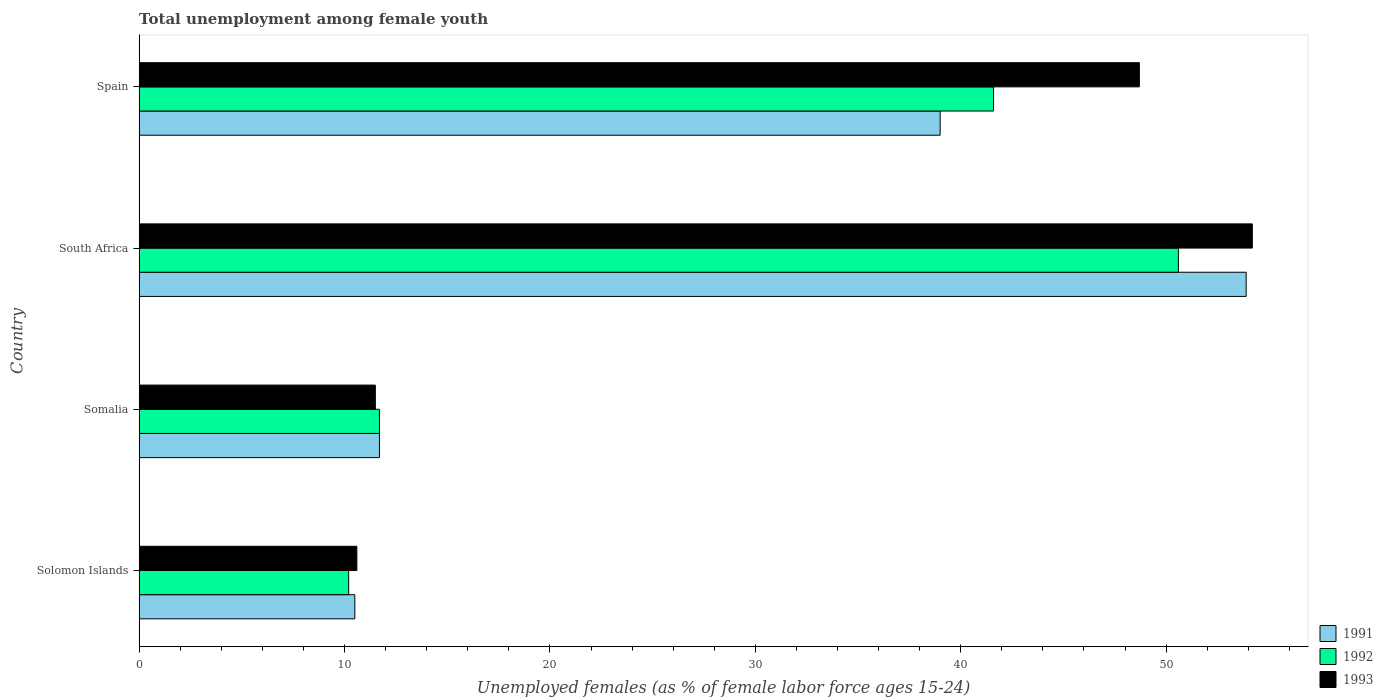How many different coloured bars are there?
Provide a succinct answer. 3. How many groups of bars are there?
Make the answer very short. 4. Are the number of bars per tick equal to the number of legend labels?
Ensure brevity in your answer.  Yes. How many bars are there on the 4th tick from the top?
Your answer should be compact. 3. What is the label of the 3rd group of bars from the top?
Provide a succinct answer. Somalia. Across all countries, what is the maximum percentage of unemployed females in in 1993?
Provide a short and direct response. 54.2. Across all countries, what is the minimum percentage of unemployed females in in 1992?
Provide a short and direct response. 10.2. In which country was the percentage of unemployed females in in 1991 maximum?
Ensure brevity in your answer.  South Africa. In which country was the percentage of unemployed females in in 1992 minimum?
Offer a terse response. Solomon Islands. What is the total percentage of unemployed females in in 1993 in the graph?
Provide a short and direct response. 125. What is the difference between the percentage of unemployed females in in 1993 in Solomon Islands and that in South Africa?
Ensure brevity in your answer.  -43.6. What is the difference between the percentage of unemployed females in in 1992 in Spain and the percentage of unemployed females in in 1993 in Solomon Islands?
Provide a succinct answer. 31. What is the average percentage of unemployed females in in 1993 per country?
Your answer should be very brief. 31.25. What is the difference between the percentage of unemployed females in in 1991 and percentage of unemployed females in in 1993 in Spain?
Ensure brevity in your answer.  -9.7. In how many countries, is the percentage of unemployed females in in 1993 greater than 16 %?
Provide a succinct answer. 2. What is the ratio of the percentage of unemployed females in in 1993 in Somalia to that in South Africa?
Ensure brevity in your answer.  0.21. What is the difference between the highest and the second highest percentage of unemployed females in in 1991?
Give a very brief answer. 14.9. What is the difference between the highest and the lowest percentage of unemployed females in in 1993?
Ensure brevity in your answer.  43.6. Is the sum of the percentage of unemployed females in in 1991 in South Africa and Spain greater than the maximum percentage of unemployed females in in 1993 across all countries?
Provide a succinct answer. Yes. What does the 2nd bar from the top in Somalia represents?
Your response must be concise. 1992. How many bars are there?
Make the answer very short. 12. How many countries are there in the graph?
Your answer should be compact. 4. What is the difference between two consecutive major ticks on the X-axis?
Your response must be concise. 10. Are the values on the major ticks of X-axis written in scientific E-notation?
Offer a very short reply. No. Does the graph contain any zero values?
Keep it short and to the point. No. Where does the legend appear in the graph?
Provide a succinct answer. Bottom right. What is the title of the graph?
Your answer should be compact. Total unemployment among female youth. Does "1997" appear as one of the legend labels in the graph?
Make the answer very short. No. What is the label or title of the X-axis?
Keep it short and to the point. Unemployed females (as % of female labor force ages 15-24). What is the label or title of the Y-axis?
Make the answer very short. Country. What is the Unemployed females (as % of female labor force ages 15-24) of 1991 in Solomon Islands?
Provide a short and direct response. 10.5. What is the Unemployed females (as % of female labor force ages 15-24) in 1992 in Solomon Islands?
Your answer should be compact. 10.2. What is the Unemployed females (as % of female labor force ages 15-24) of 1993 in Solomon Islands?
Provide a short and direct response. 10.6. What is the Unemployed females (as % of female labor force ages 15-24) of 1991 in Somalia?
Your response must be concise. 11.7. What is the Unemployed females (as % of female labor force ages 15-24) of 1992 in Somalia?
Offer a terse response. 11.7. What is the Unemployed females (as % of female labor force ages 15-24) of 1993 in Somalia?
Your response must be concise. 11.5. What is the Unemployed females (as % of female labor force ages 15-24) of 1991 in South Africa?
Your answer should be very brief. 53.9. What is the Unemployed females (as % of female labor force ages 15-24) in 1992 in South Africa?
Make the answer very short. 50.6. What is the Unemployed females (as % of female labor force ages 15-24) in 1993 in South Africa?
Ensure brevity in your answer.  54.2. What is the Unemployed females (as % of female labor force ages 15-24) in 1991 in Spain?
Give a very brief answer. 39. What is the Unemployed females (as % of female labor force ages 15-24) of 1992 in Spain?
Your answer should be very brief. 41.6. What is the Unemployed females (as % of female labor force ages 15-24) of 1993 in Spain?
Give a very brief answer. 48.7. Across all countries, what is the maximum Unemployed females (as % of female labor force ages 15-24) of 1991?
Offer a terse response. 53.9. Across all countries, what is the maximum Unemployed females (as % of female labor force ages 15-24) of 1992?
Provide a succinct answer. 50.6. Across all countries, what is the maximum Unemployed females (as % of female labor force ages 15-24) of 1993?
Keep it short and to the point. 54.2. Across all countries, what is the minimum Unemployed females (as % of female labor force ages 15-24) in 1991?
Make the answer very short. 10.5. Across all countries, what is the minimum Unemployed females (as % of female labor force ages 15-24) of 1992?
Ensure brevity in your answer.  10.2. Across all countries, what is the minimum Unemployed females (as % of female labor force ages 15-24) of 1993?
Give a very brief answer. 10.6. What is the total Unemployed females (as % of female labor force ages 15-24) in 1991 in the graph?
Your answer should be compact. 115.1. What is the total Unemployed females (as % of female labor force ages 15-24) of 1992 in the graph?
Keep it short and to the point. 114.1. What is the total Unemployed females (as % of female labor force ages 15-24) in 1993 in the graph?
Ensure brevity in your answer.  125. What is the difference between the Unemployed females (as % of female labor force ages 15-24) of 1991 in Solomon Islands and that in Somalia?
Your response must be concise. -1.2. What is the difference between the Unemployed females (as % of female labor force ages 15-24) of 1991 in Solomon Islands and that in South Africa?
Give a very brief answer. -43.4. What is the difference between the Unemployed females (as % of female labor force ages 15-24) of 1992 in Solomon Islands and that in South Africa?
Offer a very short reply. -40.4. What is the difference between the Unemployed females (as % of female labor force ages 15-24) in 1993 in Solomon Islands and that in South Africa?
Provide a short and direct response. -43.6. What is the difference between the Unemployed females (as % of female labor force ages 15-24) of 1991 in Solomon Islands and that in Spain?
Offer a terse response. -28.5. What is the difference between the Unemployed females (as % of female labor force ages 15-24) in 1992 in Solomon Islands and that in Spain?
Offer a terse response. -31.4. What is the difference between the Unemployed females (as % of female labor force ages 15-24) in 1993 in Solomon Islands and that in Spain?
Offer a very short reply. -38.1. What is the difference between the Unemployed females (as % of female labor force ages 15-24) of 1991 in Somalia and that in South Africa?
Make the answer very short. -42.2. What is the difference between the Unemployed females (as % of female labor force ages 15-24) in 1992 in Somalia and that in South Africa?
Your answer should be very brief. -38.9. What is the difference between the Unemployed females (as % of female labor force ages 15-24) of 1993 in Somalia and that in South Africa?
Your answer should be very brief. -42.7. What is the difference between the Unemployed females (as % of female labor force ages 15-24) in 1991 in Somalia and that in Spain?
Your answer should be very brief. -27.3. What is the difference between the Unemployed females (as % of female labor force ages 15-24) in 1992 in Somalia and that in Spain?
Your response must be concise. -29.9. What is the difference between the Unemployed females (as % of female labor force ages 15-24) in 1993 in Somalia and that in Spain?
Provide a short and direct response. -37.2. What is the difference between the Unemployed females (as % of female labor force ages 15-24) of 1992 in South Africa and that in Spain?
Your response must be concise. 9. What is the difference between the Unemployed females (as % of female labor force ages 15-24) of 1991 in Solomon Islands and the Unemployed females (as % of female labor force ages 15-24) of 1993 in Somalia?
Offer a terse response. -1. What is the difference between the Unemployed females (as % of female labor force ages 15-24) in 1992 in Solomon Islands and the Unemployed females (as % of female labor force ages 15-24) in 1993 in Somalia?
Your answer should be compact. -1.3. What is the difference between the Unemployed females (as % of female labor force ages 15-24) of 1991 in Solomon Islands and the Unemployed females (as % of female labor force ages 15-24) of 1992 in South Africa?
Ensure brevity in your answer.  -40.1. What is the difference between the Unemployed females (as % of female labor force ages 15-24) of 1991 in Solomon Islands and the Unemployed females (as % of female labor force ages 15-24) of 1993 in South Africa?
Provide a succinct answer. -43.7. What is the difference between the Unemployed females (as % of female labor force ages 15-24) of 1992 in Solomon Islands and the Unemployed females (as % of female labor force ages 15-24) of 1993 in South Africa?
Offer a terse response. -44. What is the difference between the Unemployed females (as % of female labor force ages 15-24) in 1991 in Solomon Islands and the Unemployed females (as % of female labor force ages 15-24) in 1992 in Spain?
Make the answer very short. -31.1. What is the difference between the Unemployed females (as % of female labor force ages 15-24) of 1991 in Solomon Islands and the Unemployed females (as % of female labor force ages 15-24) of 1993 in Spain?
Make the answer very short. -38.2. What is the difference between the Unemployed females (as % of female labor force ages 15-24) of 1992 in Solomon Islands and the Unemployed females (as % of female labor force ages 15-24) of 1993 in Spain?
Provide a succinct answer. -38.5. What is the difference between the Unemployed females (as % of female labor force ages 15-24) in 1991 in Somalia and the Unemployed females (as % of female labor force ages 15-24) in 1992 in South Africa?
Make the answer very short. -38.9. What is the difference between the Unemployed females (as % of female labor force ages 15-24) in 1991 in Somalia and the Unemployed females (as % of female labor force ages 15-24) in 1993 in South Africa?
Your answer should be compact. -42.5. What is the difference between the Unemployed females (as % of female labor force ages 15-24) of 1992 in Somalia and the Unemployed females (as % of female labor force ages 15-24) of 1993 in South Africa?
Give a very brief answer. -42.5. What is the difference between the Unemployed females (as % of female labor force ages 15-24) of 1991 in Somalia and the Unemployed females (as % of female labor force ages 15-24) of 1992 in Spain?
Keep it short and to the point. -29.9. What is the difference between the Unemployed females (as % of female labor force ages 15-24) in 1991 in Somalia and the Unemployed females (as % of female labor force ages 15-24) in 1993 in Spain?
Your answer should be very brief. -37. What is the difference between the Unemployed females (as % of female labor force ages 15-24) in 1992 in Somalia and the Unemployed females (as % of female labor force ages 15-24) in 1993 in Spain?
Give a very brief answer. -37. What is the difference between the Unemployed females (as % of female labor force ages 15-24) in 1991 in South Africa and the Unemployed females (as % of female labor force ages 15-24) in 1993 in Spain?
Your response must be concise. 5.2. What is the average Unemployed females (as % of female labor force ages 15-24) of 1991 per country?
Make the answer very short. 28.77. What is the average Unemployed females (as % of female labor force ages 15-24) in 1992 per country?
Your answer should be compact. 28.52. What is the average Unemployed females (as % of female labor force ages 15-24) in 1993 per country?
Provide a succinct answer. 31.25. What is the difference between the Unemployed females (as % of female labor force ages 15-24) in 1991 and Unemployed females (as % of female labor force ages 15-24) in 1992 in Solomon Islands?
Provide a short and direct response. 0.3. What is the difference between the Unemployed females (as % of female labor force ages 15-24) in 1991 and Unemployed females (as % of female labor force ages 15-24) in 1993 in Solomon Islands?
Keep it short and to the point. -0.1. What is the difference between the Unemployed females (as % of female labor force ages 15-24) of 1991 and Unemployed females (as % of female labor force ages 15-24) of 1992 in Somalia?
Provide a succinct answer. 0. What is the difference between the Unemployed females (as % of female labor force ages 15-24) in 1991 and Unemployed females (as % of female labor force ages 15-24) in 1992 in South Africa?
Your response must be concise. 3.3. What is the difference between the Unemployed females (as % of female labor force ages 15-24) of 1991 and Unemployed females (as % of female labor force ages 15-24) of 1992 in Spain?
Offer a terse response. -2.6. What is the difference between the Unemployed females (as % of female labor force ages 15-24) of 1991 and Unemployed females (as % of female labor force ages 15-24) of 1993 in Spain?
Ensure brevity in your answer.  -9.7. What is the ratio of the Unemployed females (as % of female labor force ages 15-24) in 1991 in Solomon Islands to that in Somalia?
Your answer should be very brief. 0.9. What is the ratio of the Unemployed females (as % of female labor force ages 15-24) of 1992 in Solomon Islands to that in Somalia?
Provide a short and direct response. 0.87. What is the ratio of the Unemployed females (as % of female labor force ages 15-24) of 1993 in Solomon Islands to that in Somalia?
Provide a succinct answer. 0.92. What is the ratio of the Unemployed females (as % of female labor force ages 15-24) in 1991 in Solomon Islands to that in South Africa?
Give a very brief answer. 0.19. What is the ratio of the Unemployed females (as % of female labor force ages 15-24) in 1992 in Solomon Islands to that in South Africa?
Your answer should be very brief. 0.2. What is the ratio of the Unemployed females (as % of female labor force ages 15-24) in 1993 in Solomon Islands to that in South Africa?
Provide a succinct answer. 0.2. What is the ratio of the Unemployed females (as % of female labor force ages 15-24) in 1991 in Solomon Islands to that in Spain?
Provide a succinct answer. 0.27. What is the ratio of the Unemployed females (as % of female labor force ages 15-24) of 1992 in Solomon Islands to that in Spain?
Provide a succinct answer. 0.25. What is the ratio of the Unemployed females (as % of female labor force ages 15-24) of 1993 in Solomon Islands to that in Spain?
Give a very brief answer. 0.22. What is the ratio of the Unemployed females (as % of female labor force ages 15-24) in 1991 in Somalia to that in South Africa?
Offer a terse response. 0.22. What is the ratio of the Unemployed females (as % of female labor force ages 15-24) in 1992 in Somalia to that in South Africa?
Offer a terse response. 0.23. What is the ratio of the Unemployed females (as % of female labor force ages 15-24) of 1993 in Somalia to that in South Africa?
Your answer should be compact. 0.21. What is the ratio of the Unemployed females (as % of female labor force ages 15-24) in 1992 in Somalia to that in Spain?
Keep it short and to the point. 0.28. What is the ratio of the Unemployed females (as % of female labor force ages 15-24) in 1993 in Somalia to that in Spain?
Provide a short and direct response. 0.24. What is the ratio of the Unemployed females (as % of female labor force ages 15-24) of 1991 in South Africa to that in Spain?
Offer a terse response. 1.38. What is the ratio of the Unemployed females (as % of female labor force ages 15-24) in 1992 in South Africa to that in Spain?
Your answer should be very brief. 1.22. What is the ratio of the Unemployed females (as % of female labor force ages 15-24) in 1993 in South Africa to that in Spain?
Your response must be concise. 1.11. What is the difference between the highest and the second highest Unemployed females (as % of female labor force ages 15-24) of 1991?
Your answer should be compact. 14.9. What is the difference between the highest and the second highest Unemployed females (as % of female labor force ages 15-24) in 1992?
Provide a short and direct response. 9. What is the difference between the highest and the lowest Unemployed females (as % of female labor force ages 15-24) in 1991?
Your answer should be very brief. 43.4. What is the difference between the highest and the lowest Unemployed females (as % of female labor force ages 15-24) in 1992?
Your answer should be compact. 40.4. What is the difference between the highest and the lowest Unemployed females (as % of female labor force ages 15-24) in 1993?
Your answer should be very brief. 43.6. 